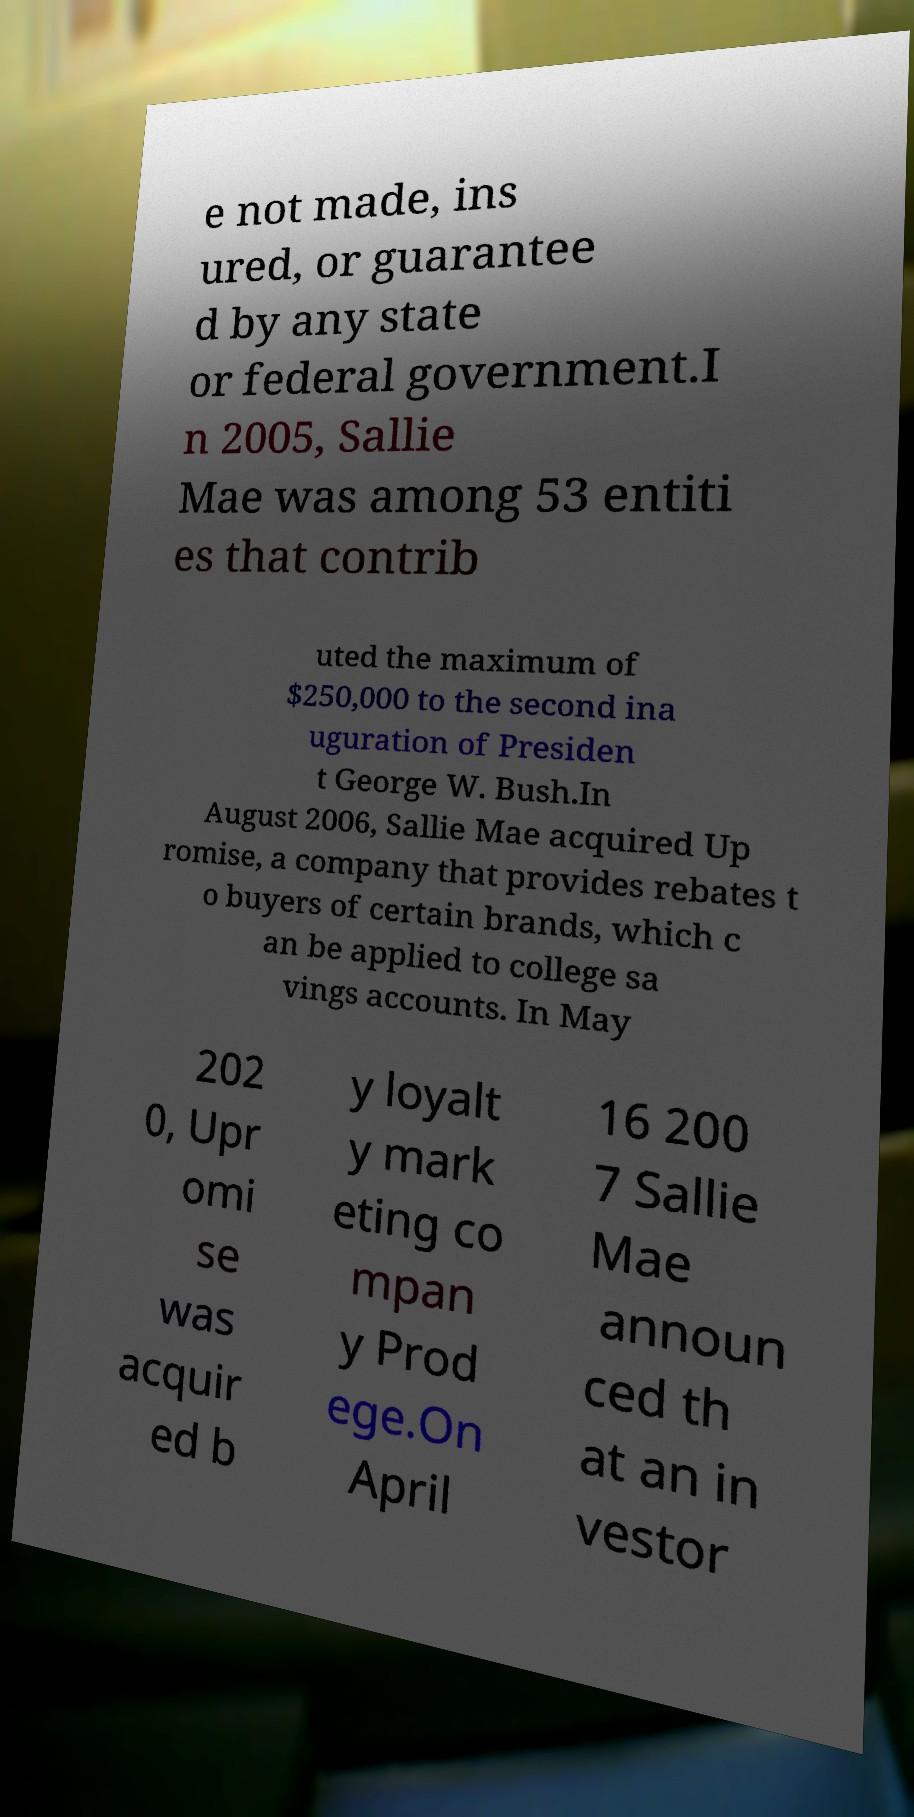Please read and relay the text visible in this image. What does it say? e not made, ins ured, or guarantee d by any state or federal government.I n 2005, Sallie Mae was among 53 entiti es that contrib uted the maximum of $250,000 to the second ina uguration of Presiden t George W. Bush.In August 2006, Sallie Mae acquired Up romise, a company that provides rebates t o buyers of certain brands, which c an be applied to college sa vings accounts. In May 202 0, Upr omi se was acquir ed b y loyalt y mark eting co mpan y Prod ege.On April 16 200 7 Sallie Mae announ ced th at an in vestor 